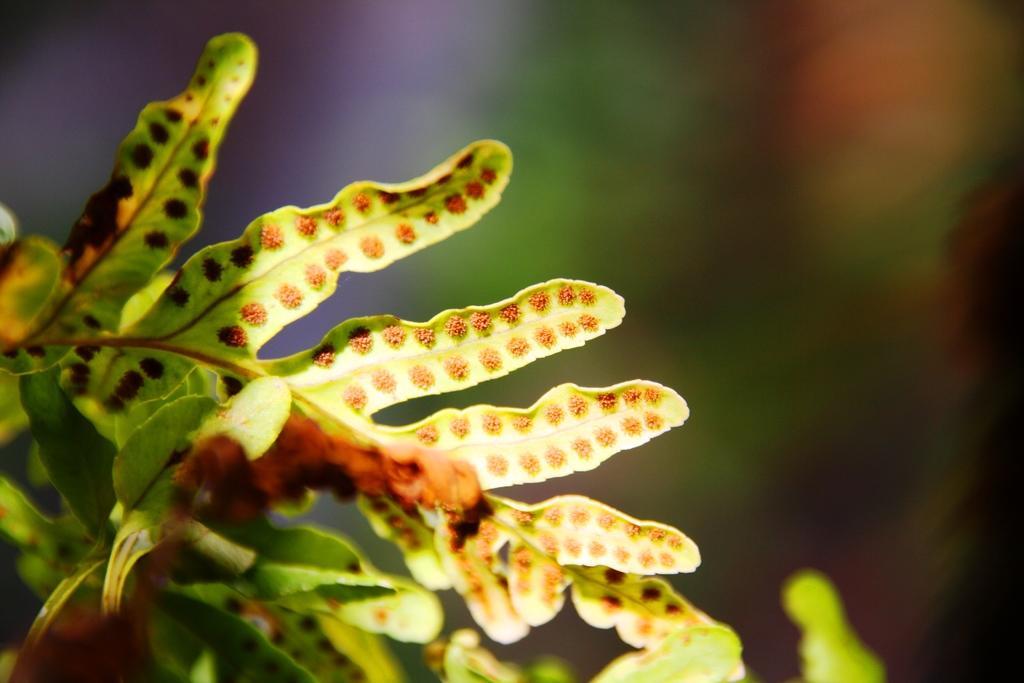Can you describe this image briefly? In this picture we can see leaves and in the background we can see it is blurry. 